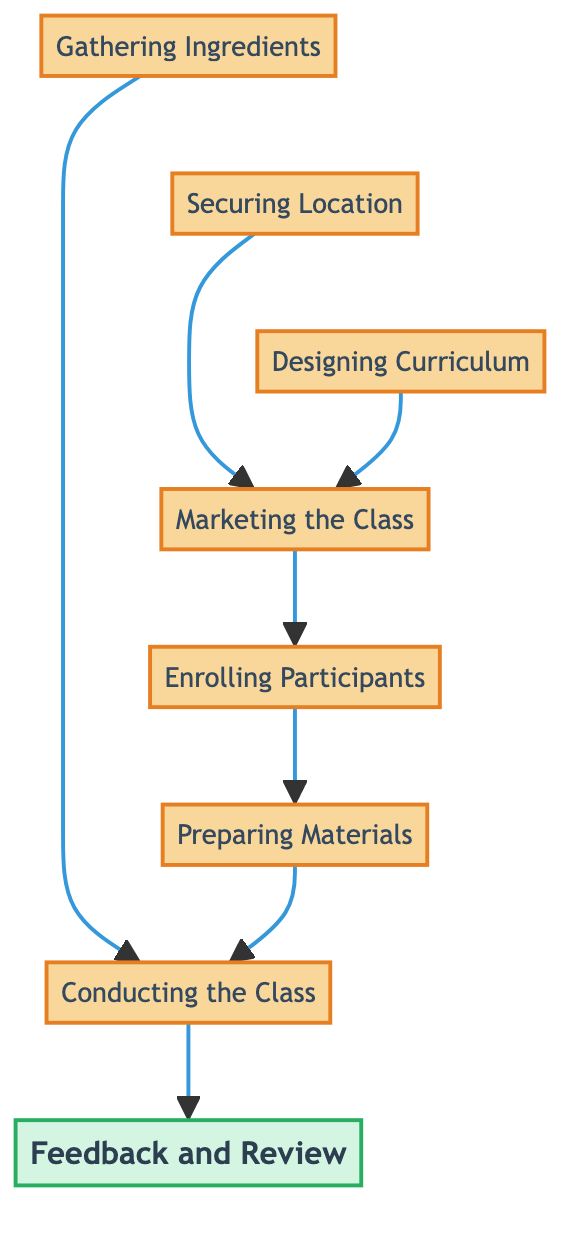What is the starting step in the process? The diagram illustrates the process of organizing a traditional Indian cooking class, which begins with "Gathering Ingredients". This step has no dependencies and serves as the foundation for the activities that follow.
Answer: Gathering Ingredients How many total steps are there in the process? By counting each distinct node in the diagram, we find there are eight steps: Gathering Ingredients, Securing Location, Designing Curriculum, Marketing the Class, Enrolling Participants, Preparing Materials, Conducting the Class, and Feedback and Review.
Answer: 8 Which steps must be completed before "Marketing the Class"? "Marketing the Class" is dependent on two previous steps: "Designing Curriculum" and "Securing Location". Both these steps must be completed to begin the marketing process.
Answer: Designing Curriculum, Securing Location What follows after "Conducting the Class"? The diagram shows that "Conducting the Class" leads to "Feedback and Review", indicating that after the class is conducted, feedback will be collected for improvement.
Answer: Feedback and Review Which step comes directly before "Preparing Materials"? The step that comes directly before "Preparing Materials" is "Enrolling Participants". This indicates that participants must be enrolled before materials can be prepared.
Answer: Enrolling Participants Is "Gathering Ingredients" linked to any other step apart from "Conducting the Class"? The only connection of "Gathering Ingredients" in the diagram is to "Conducting the Class". There are no other steps linked to it, meaning it serves a unique function in the flow.
Answer: No What are the last steps of the process? The last step in the process, indicated at the top of the flow chart, is "Feedback and Review", which encapsulates the final activity of collecting participant feedback after the class.
Answer: Feedback and Review What must happen before participants can be enrolled? Before participants can be enrolled, "Marketing the Class" needs to be completed. This ensures that potential participants are aware of the class and have the opportunity to register.
Answer: Marketing the Class 